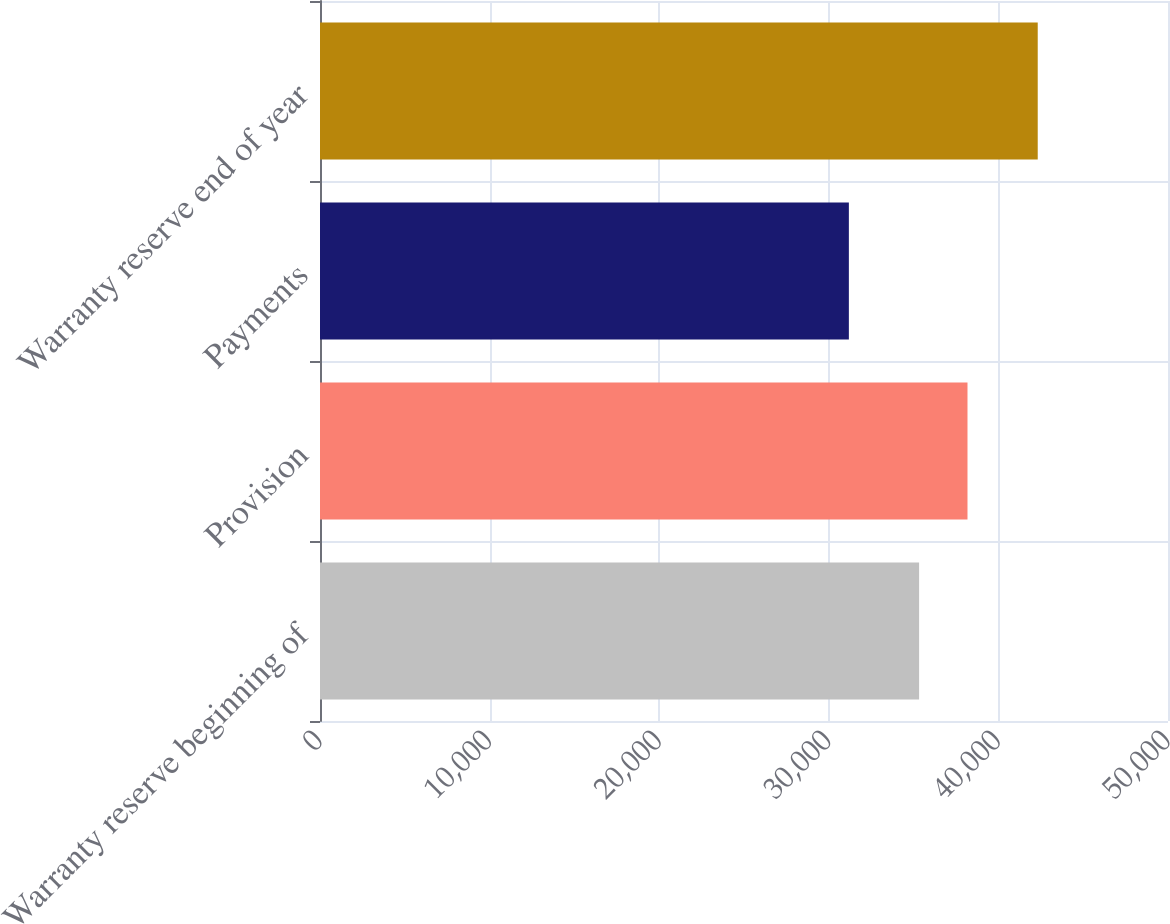<chart> <loc_0><loc_0><loc_500><loc_500><bar_chart><fcel>Warranty reserve beginning of<fcel>Provision<fcel>Payments<fcel>Warranty reserve end of year<nl><fcel>35324<fcel>38178<fcel>31183<fcel>42319<nl></chart> 